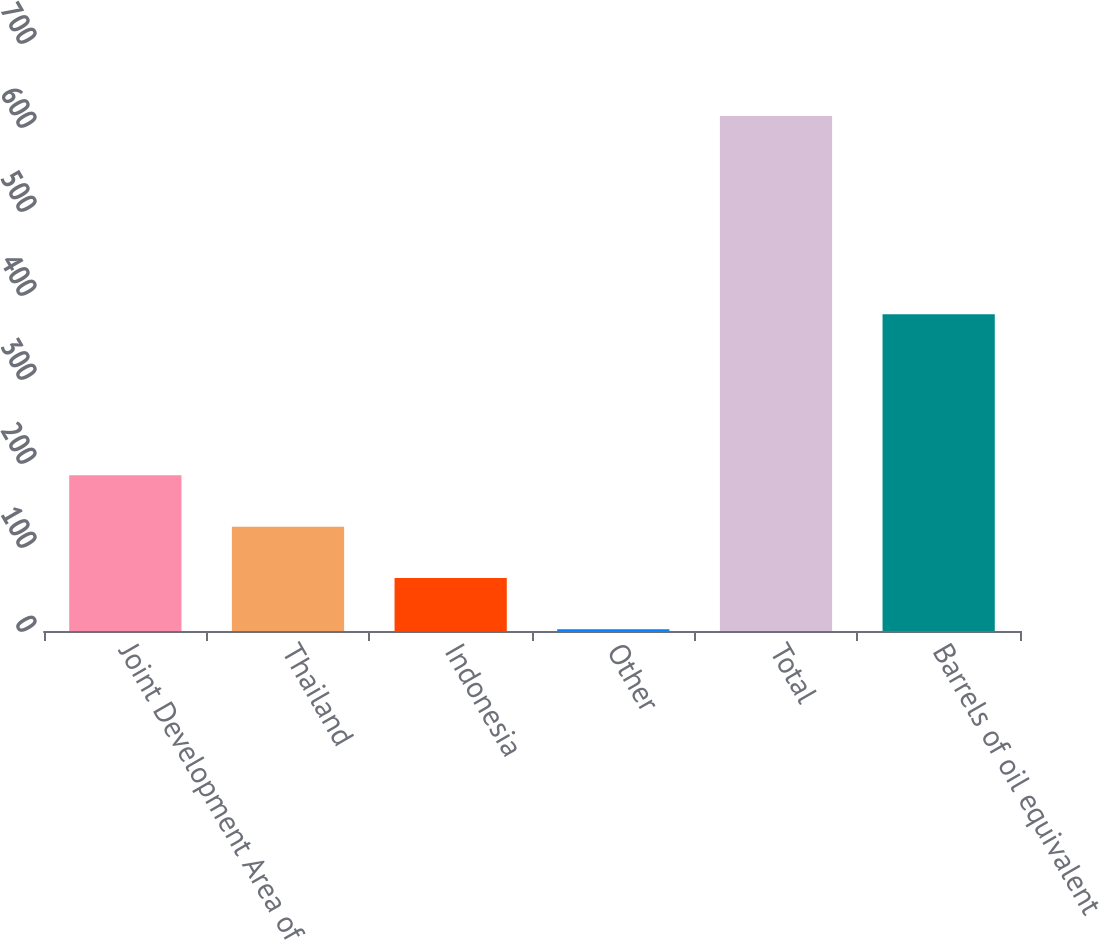<chart> <loc_0><loc_0><loc_500><loc_500><bar_chart><fcel>Joint Development Area of<fcel>Thailand<fcel>Indonesia<fcel>Other<fcel>Total<fcel>Barrels of oil equivalent<nl><fcel>185.3<fcel>124.2<fcel>63.1<fcel>2<fcel>613<fcel>377<nl></chart> 